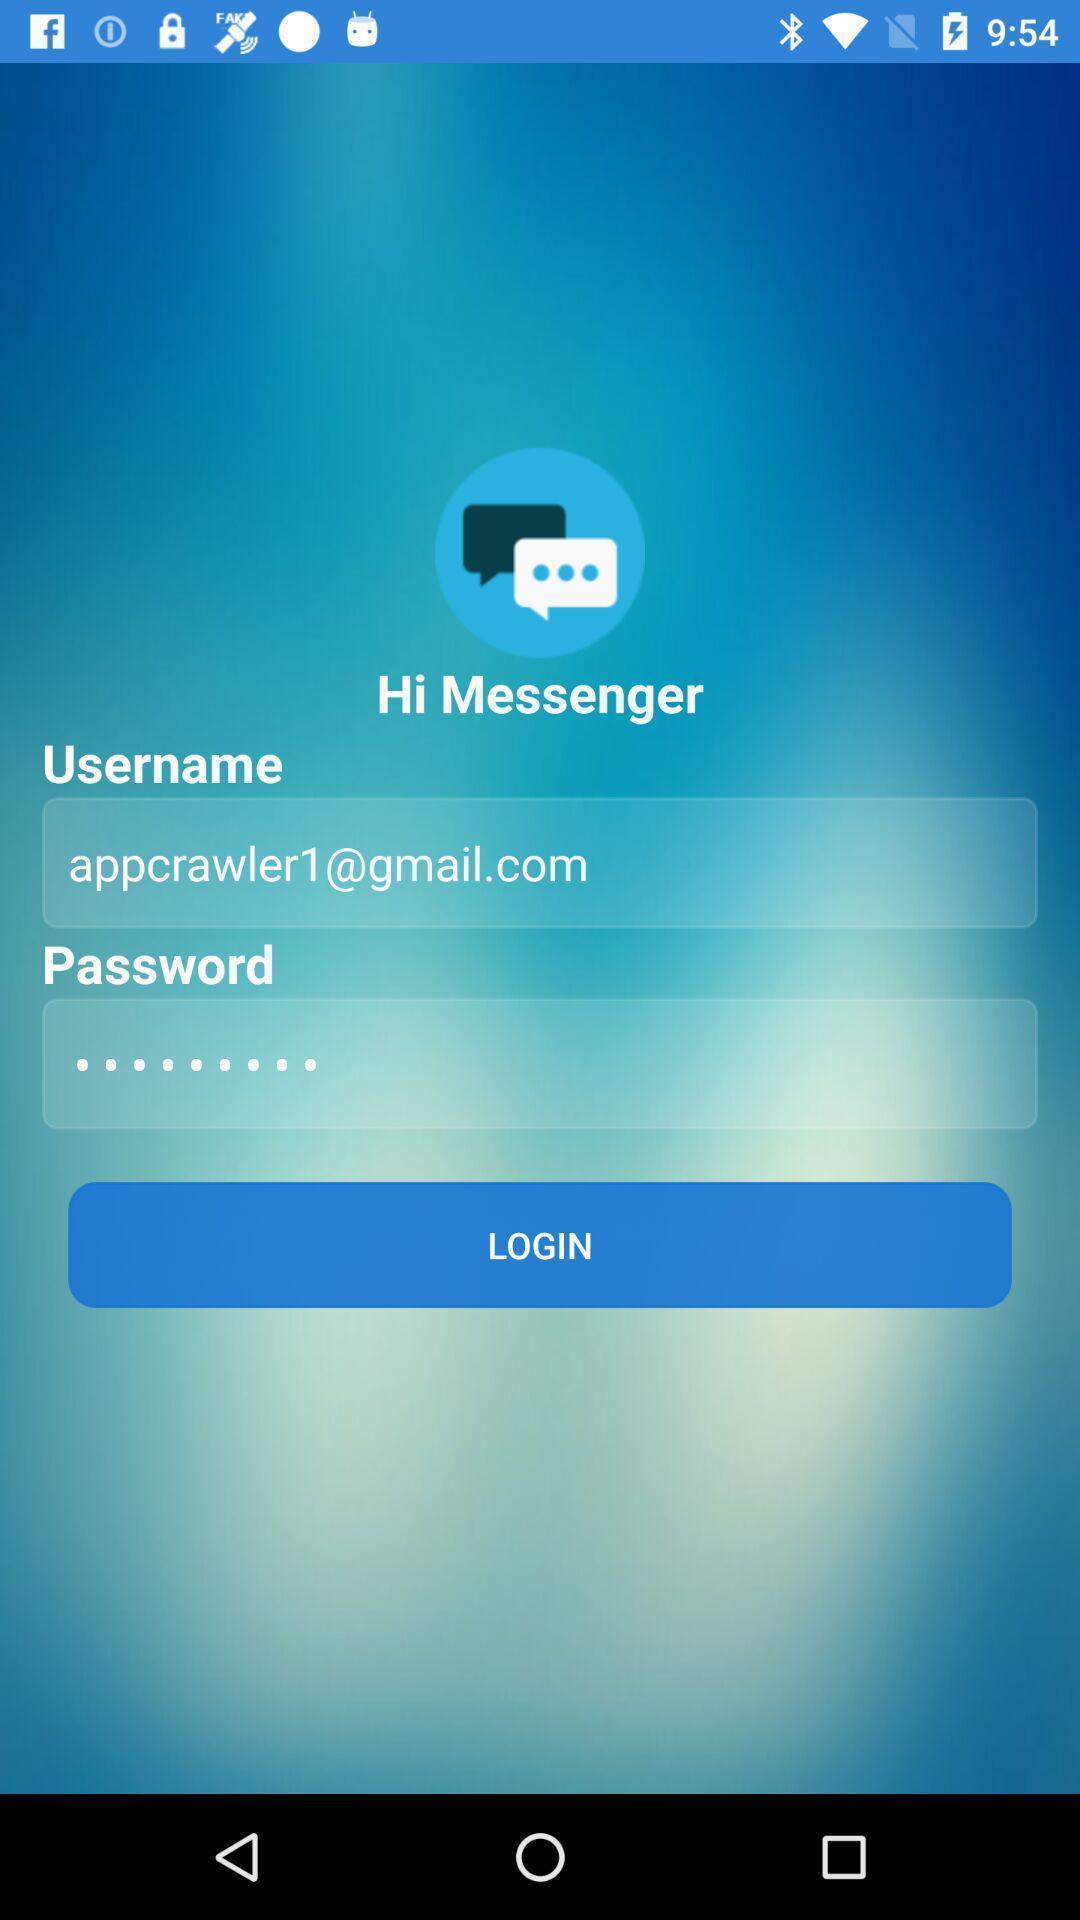Provide a description of this screenshot. Welcome to the login page. 